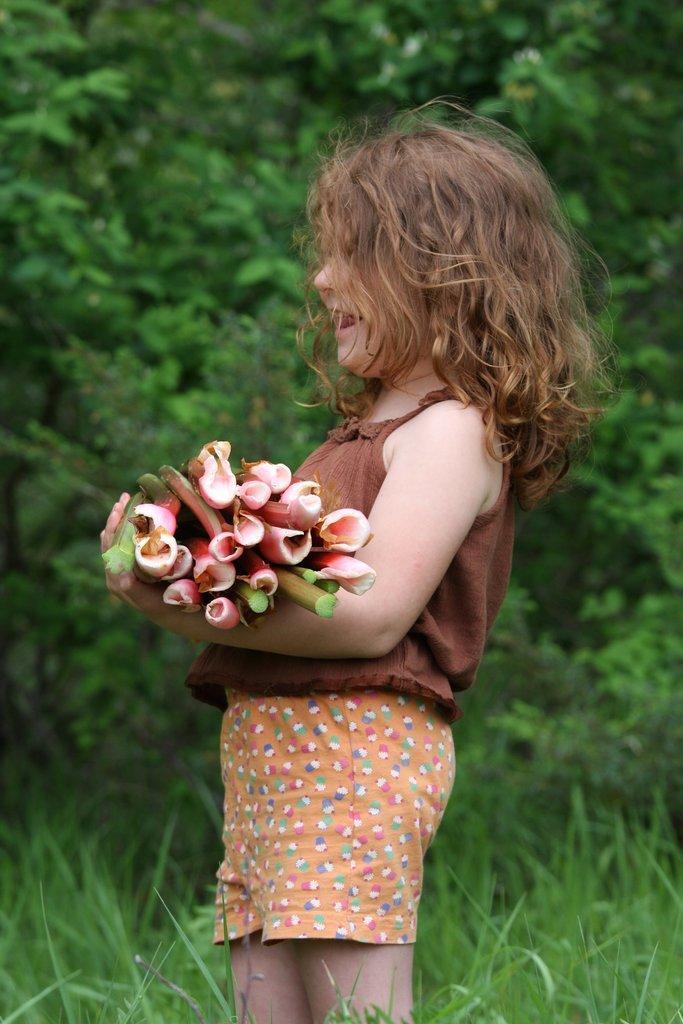Please provide a concise description of this image. In this image we can see a little girl with curly hair holding a bunch of flowers in her hand. And we can see the background is green with trees and in the bottom grass is seen. 